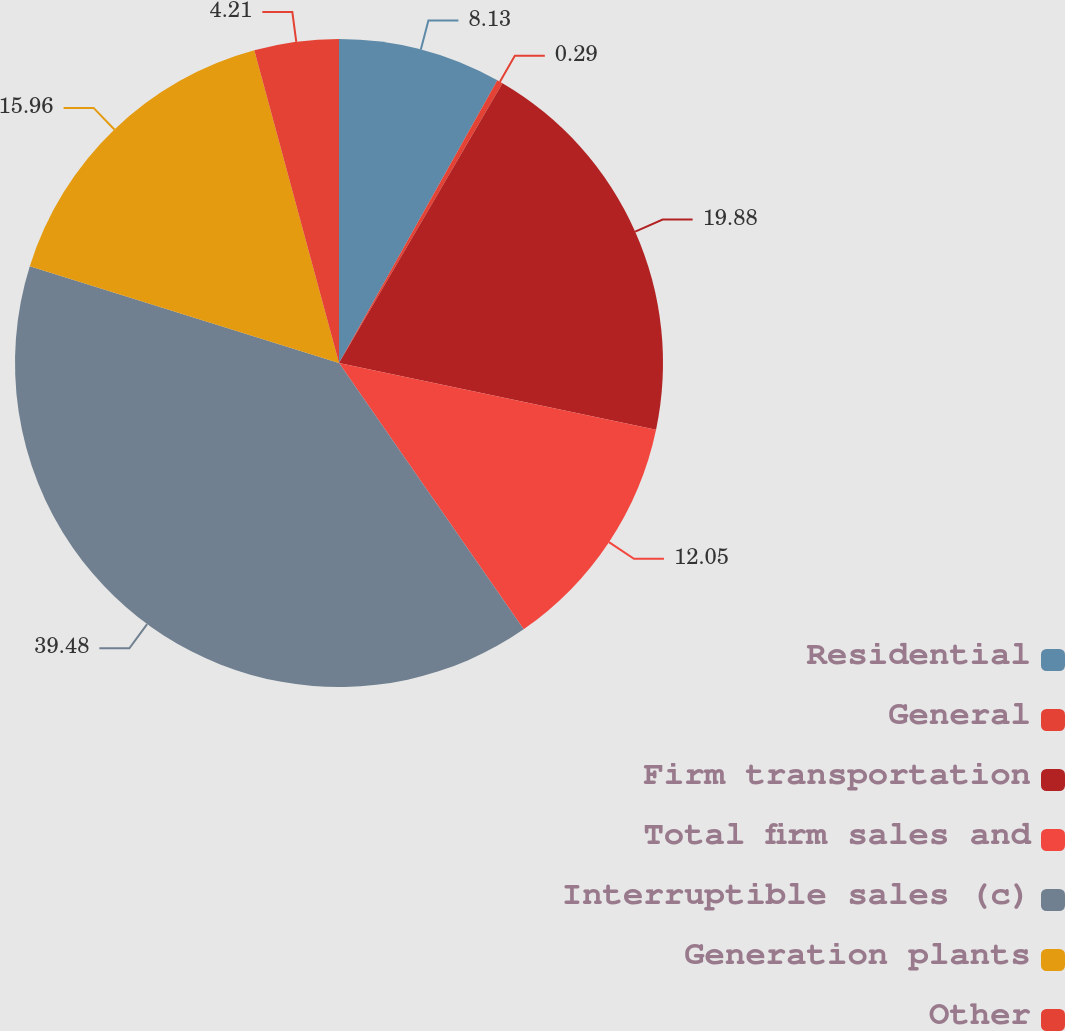Convert chart to OTSL. <chart><loc_0><loc_0><loc_500><loc_500><pie_chart><fcel>Residential<fcel>General<fcel>Firm transportation<fcel>Total firm sales and<fcel>Interruptible sales (c)<fcel>Generation plants<fcel>Other<nl><fcel>8.13%<fcel>0.29%<fcel>19.89%<fcel>12.05%<fcel>39.49%<fcel>15.97%<fcel>4.21%<nl></chart> 